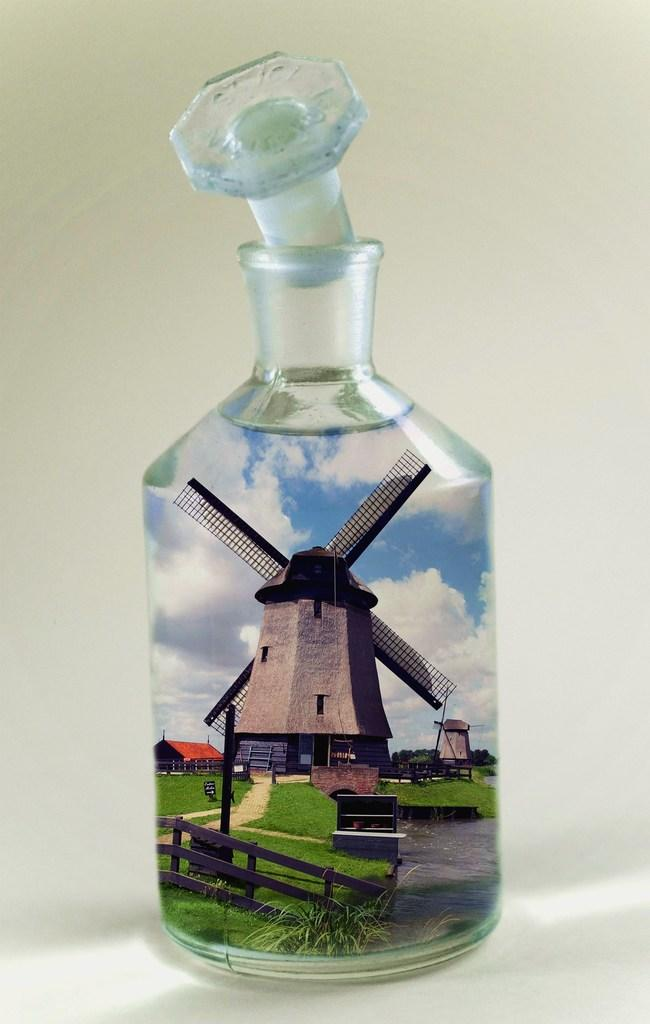What object in the image contains a windmill? The glass bottle in the image contains a windmill. What type of material is the fence in the image made of? The fence in the image is made of wood. What type of structure is visible in the image? There is a house in the image. What can be seen in the sky in the image? There are clouds visible in the image, and the sky is also visible. How is the glass bottle sealed? The glass bottle has a lid. What type of kettle is being used to hit the club in the image? There is no kettle or club present in the image. What suggestion is being made by the person in the image? There is no person in the image making a suggestion. 